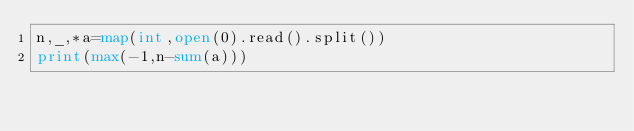<code> <loc_0><loc_0><loc_500><loc_500><_Python_>n,_,*a=map(int,open(0).read().split())
print(max(-1,n-sum(a)))</code> 